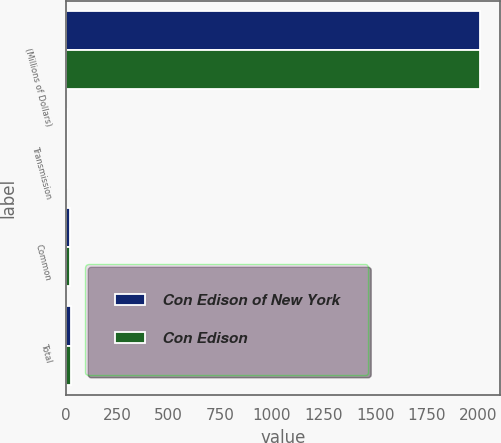Convert chart to OTSL. <chart><loc_0><loc_0><loc_500><loc_500><stacked_bar_chart><ecel><fcel>(Millions of Dollars)<fcel>Transmission<fcel>Common<fcel>Total<nl><fcel>Con Edison of New York<fcel>2007<fcel>6<fcel>22<fcel>28<nl><fcel>Con Edison<fcel>2007<fcel>6<fcel>20<fcel>26<nl></chart> 